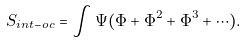Convert formula to latex. <formula><loc_0><loc_0><loc_500><loc_500>S _ { i n t - o c } = \int \Psi ( \Phi + \Phi ^ { 2 } + \Phi ^ { 3 } + \cdots ) .</formula> 